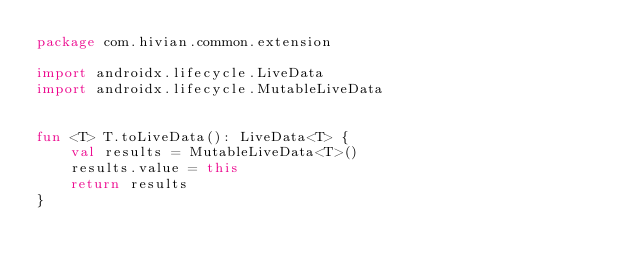<code> <loc_0><loc_0><loc_500><loc_500><_Kotlin_>package com.hivian.common.extension

import androidx.lifecycle.LiveData
import androidx.lifecycle.MutableLiveData


fun <T> T.toLiveData(): LiveData<T> {
    val results = MutableLiveData<T>()
    results.value = this
    return results
}</code> 